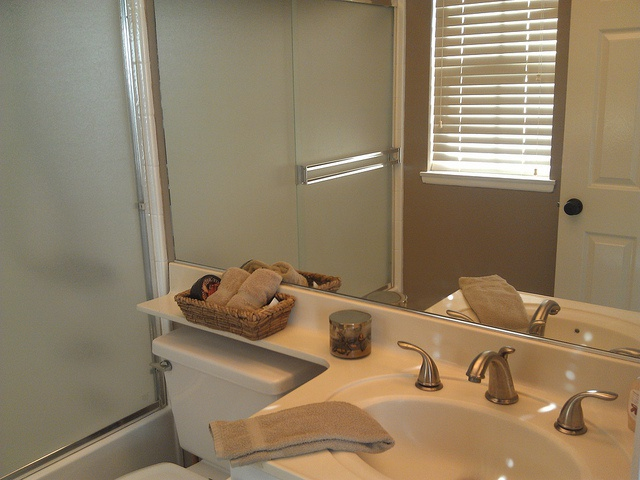Describe the objects in this image and their specific colors. I can see sink in gray and tan tones, toilet in gray tones, and cup in gray, maroon, and black tones in this image. 